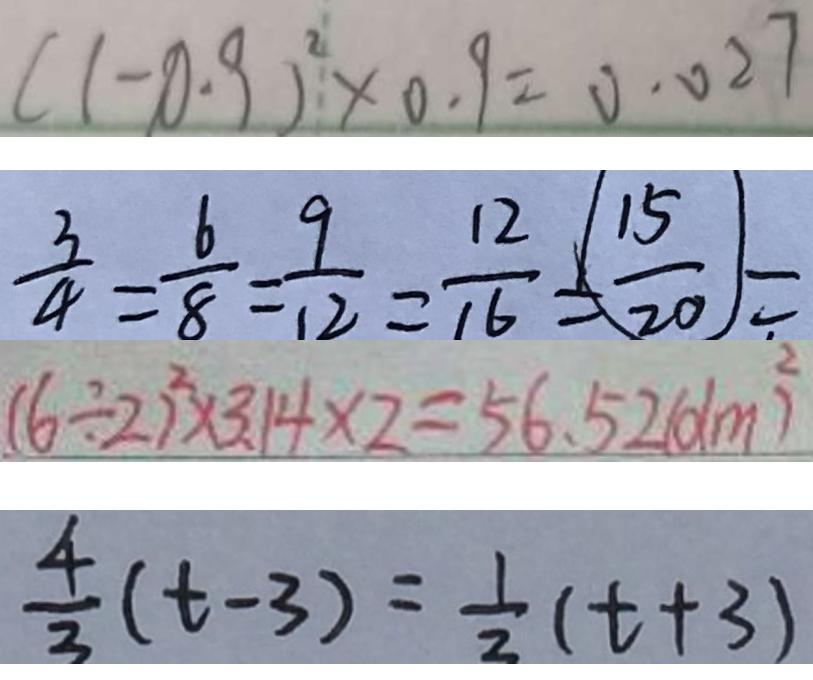Convert formula to latex. <formula><loc_0><loc_0><loc_500><loc_500>( 1 - 0 . 9 ) ^ { 2 } \times 0 . 9 = 0 . 0 2 7 
 \frac { 3 } { 4 } = \frac { 6 } { 8 } = \frac { 9 } { 1 2 } = \frac { 1 2 } { 1 6 } = \frac { 1 5 } { 2 0 } = 
 ( 6 \div 2 ) ^ { 2 } \times 3 . 1 4 \times 2 = 5 6 . 5 2 ( d m ^ { 2 } ) 
 \frac { 4 } { 3 } ( t - 3 ) = \frac { 1 } { 2 } ( t + 3 )</formula> 